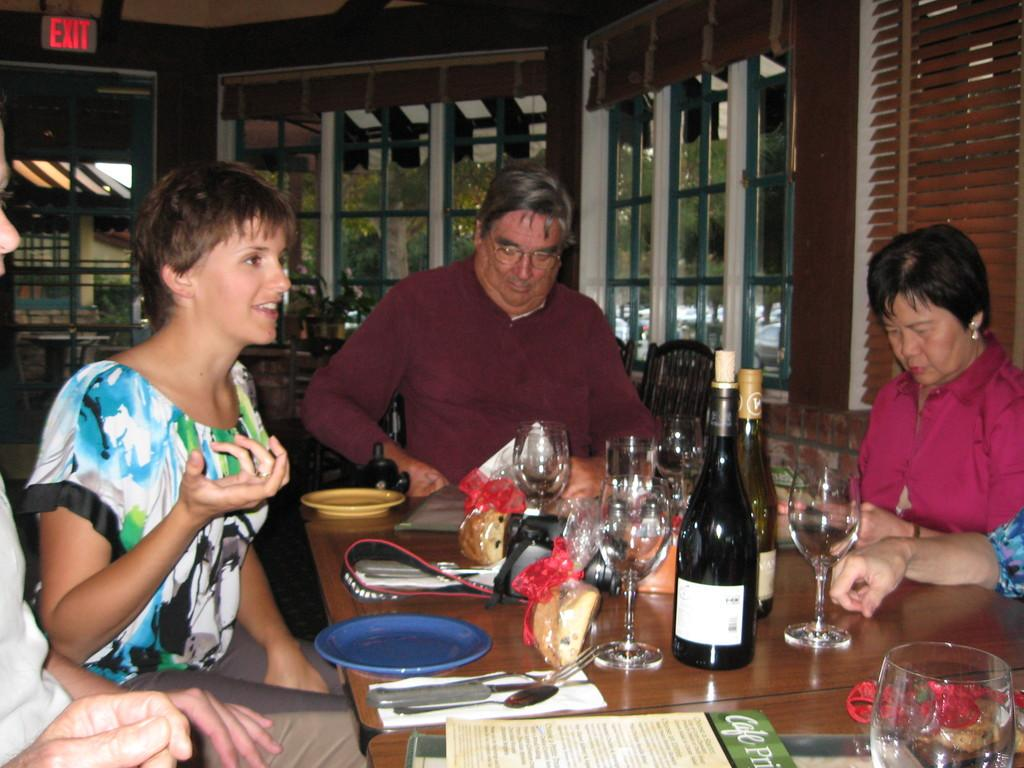How many people are in the image? There is a group of people in the image. What are the people doing in the image? The people are sitting around a table. What can be seen on the table in the image? There are wine glasses and bottles on the table. What is visible outside the window in the image? The provided facts do not mention anything visible outside the window. What type of birds can be seen flying outside the lunchroom in the image? There is no mention of a lunchroom or birds in the image. The image features a group of people sitting around a table with wine glasses and bottles. 